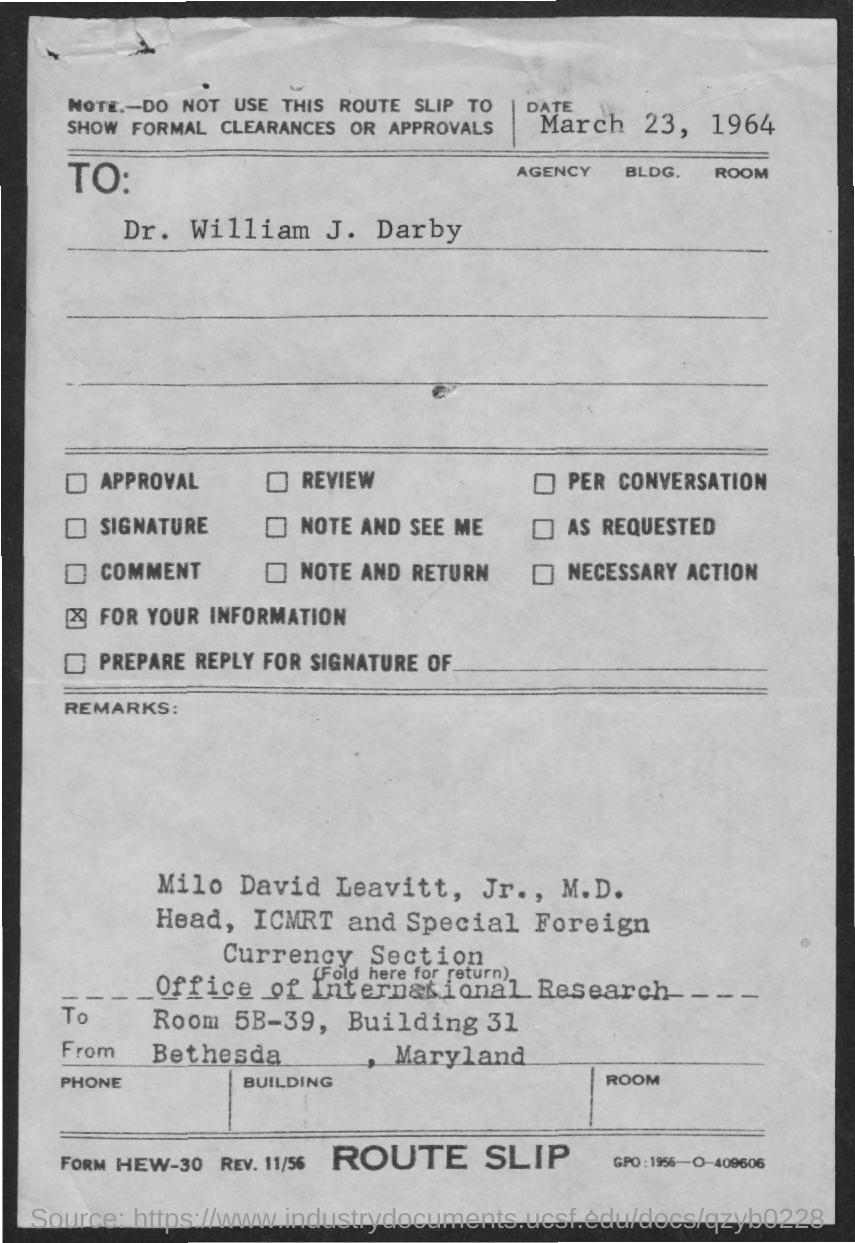What is the room number?
Give a very brief answer. 5B-39. What is the date mentioned in the document?
Offer a very short reply. March 23, 1964. Who is the head of ICMRT and the Special Foreign Currency Section?
Your answer should be compact. Milo david leavitt, jr., m.d. What is the building number?
Make the answer very short. 31. 